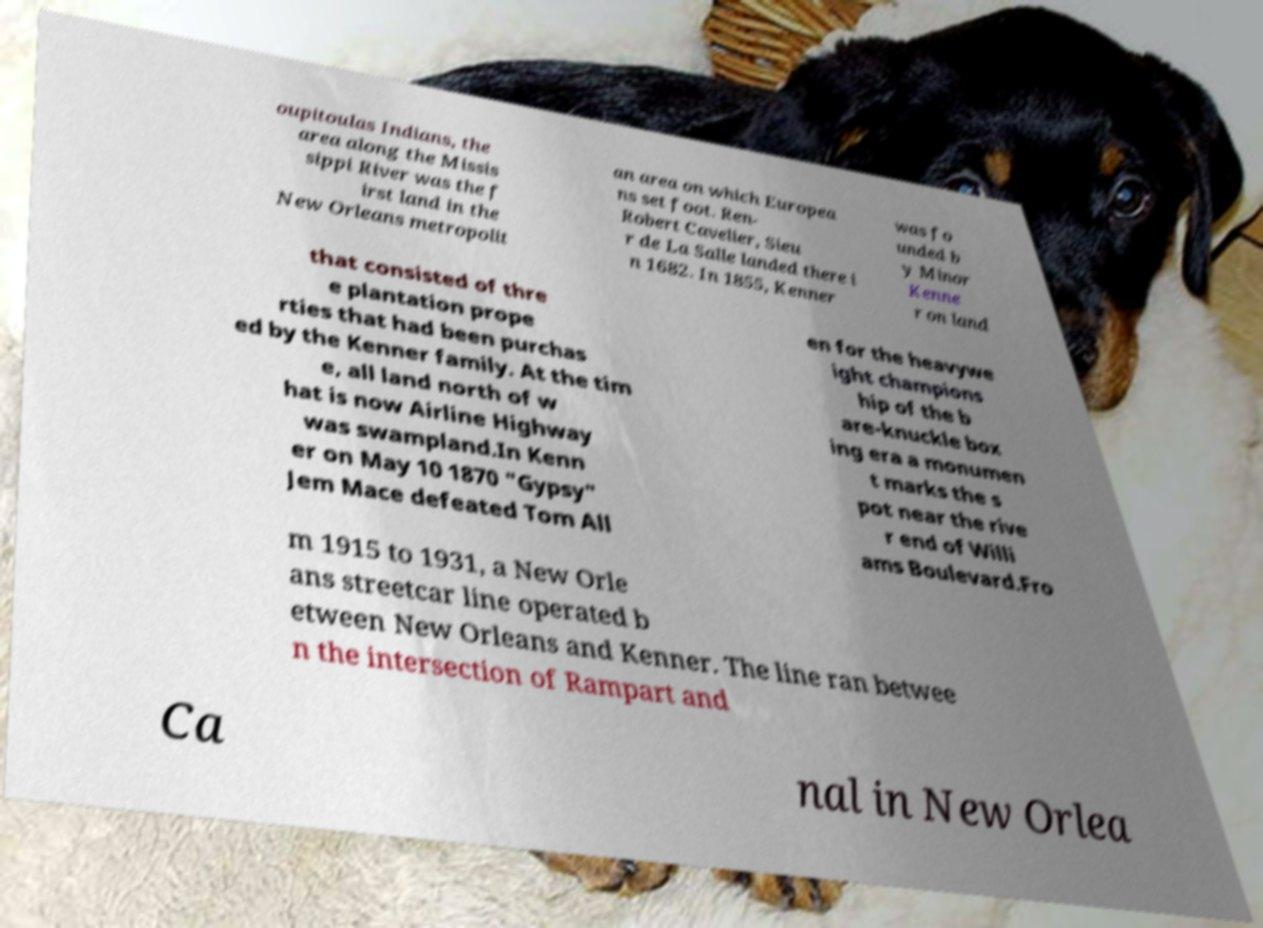Please read and relay the text visible in this image. What does it say? oupitoulas Indians, the area along the Missis sippi River was the f irst land in the New Orleans metropolit an area on which Europea ns set foot. Ren- Robert Cavelier, Sieu r de La Salle landed there i n 1682. In 1855, Kenner was fo unded b y Minor Kenne r on land that consisted of thre e plantation prope rties that had been purchas ed by the Kenner family. At the tim e, all land north of w hat is now Airline Highway was swampland.In Kenn er on May 10 1870 "Gypsy" Jem Mace defeated Tom All en for the heavywe ight champions hip of the b are-knuckle box ing era a monumen t marks the s pot near the rive r end of Willi ams Boulevard.Fro m 1915 to 1931, a New Orle ans streetcar line operated b etween New Orleans and Kenner. The line ran betwee n the intersection of Rampart and Ca nal in New Orlea 